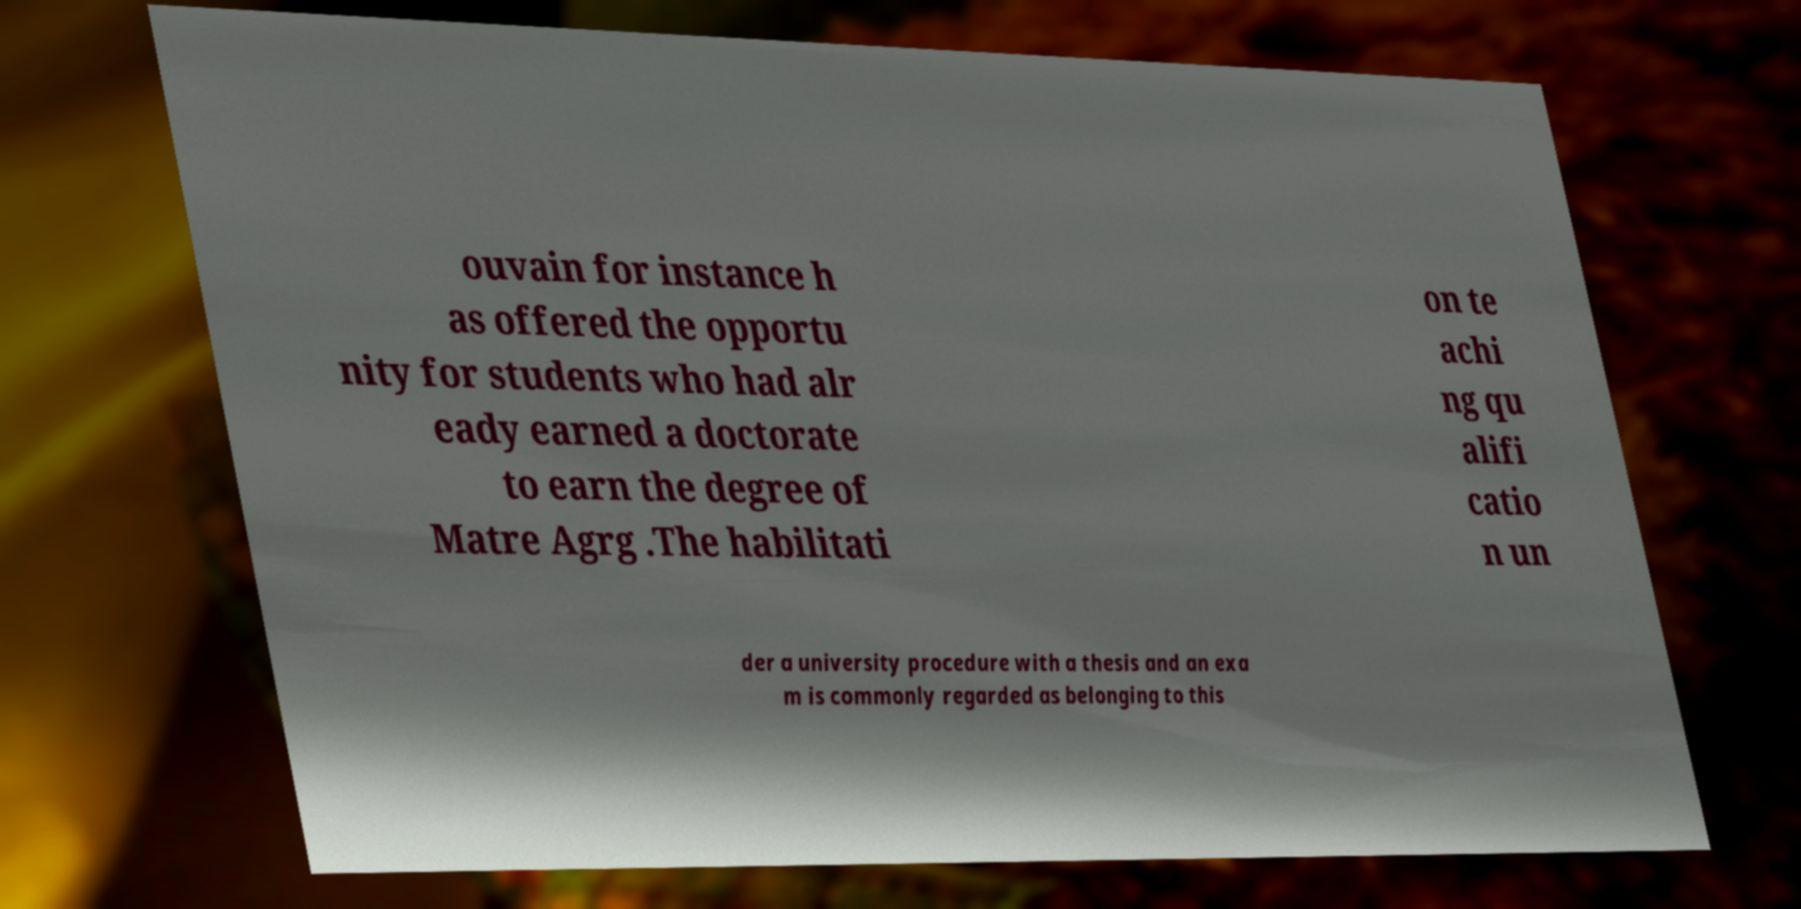I need the written content from this picture converted into text. Can you do that? ouvain for instance h as offered the opportu nity for students who had alr eady earned a doctorate to earn the degree of Matre Agrg .The habilitati on te achi ng qu alifi catio n un der a university procedure with a thesis and an exa m is commonly regarded as belonging to this 